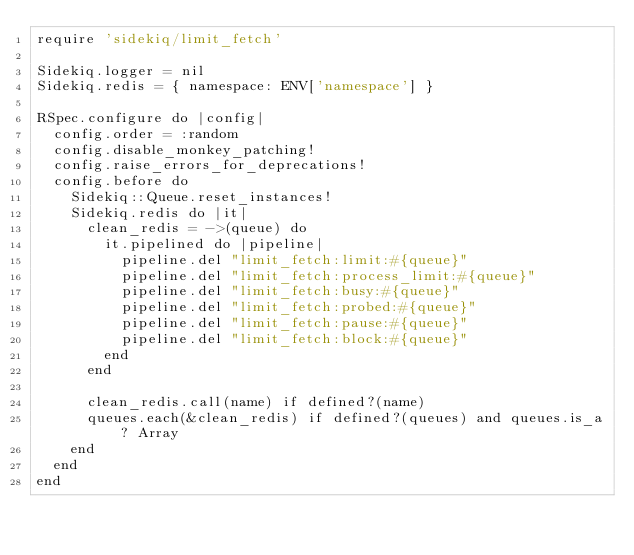Convert code to text. <code><loc_0><loc_0><loc_500><loc_500><_Ruby_>require 'sidekiq/limit_fetch'

Sidekiq.logger = nil
Sidekiq.redis = { namespace: ENV['namespace'] }

RSpec.configure do |config|
  config.order = :random
  config.disable_monkey_patching!
  config.raise_errors_for_deprecations!
  config.before do
    Sidekiq::Queue.reset_instances!
    Sidekiq.redis do |it|
      clean_redis = ->(queue) do
        it.pipelined do |pipeline|
          pipeline.del "limit_fetch:limit:#{queue}"
          pipeline.del "limit_fetch:process_limit:#{queue}"
          pipeline.del "limit_fetch:busy:#{queue}"
          pipeline.del "limit_fetch:probed:#{queue}"
          pipeline.del "limit_fetch:pause:#{queue}"
          pipeline.del "limit_fetch:block:#{queue}"
        end      
      end
      
      clean_redis.call(name) if defined?(name)
      queues.each(&clean_redis) if defined?(queues) and queues.is_a? Array
    end
  end
end
</code> 